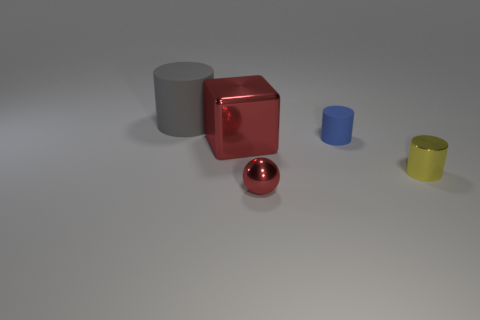What materials do the objects in the image appear to be made of? The objects in the image appear to be made of materials with a metallic finish. The cylinder, cube, and spheres are likely to be aluminum or a similar metal given their reflective surfaces. 